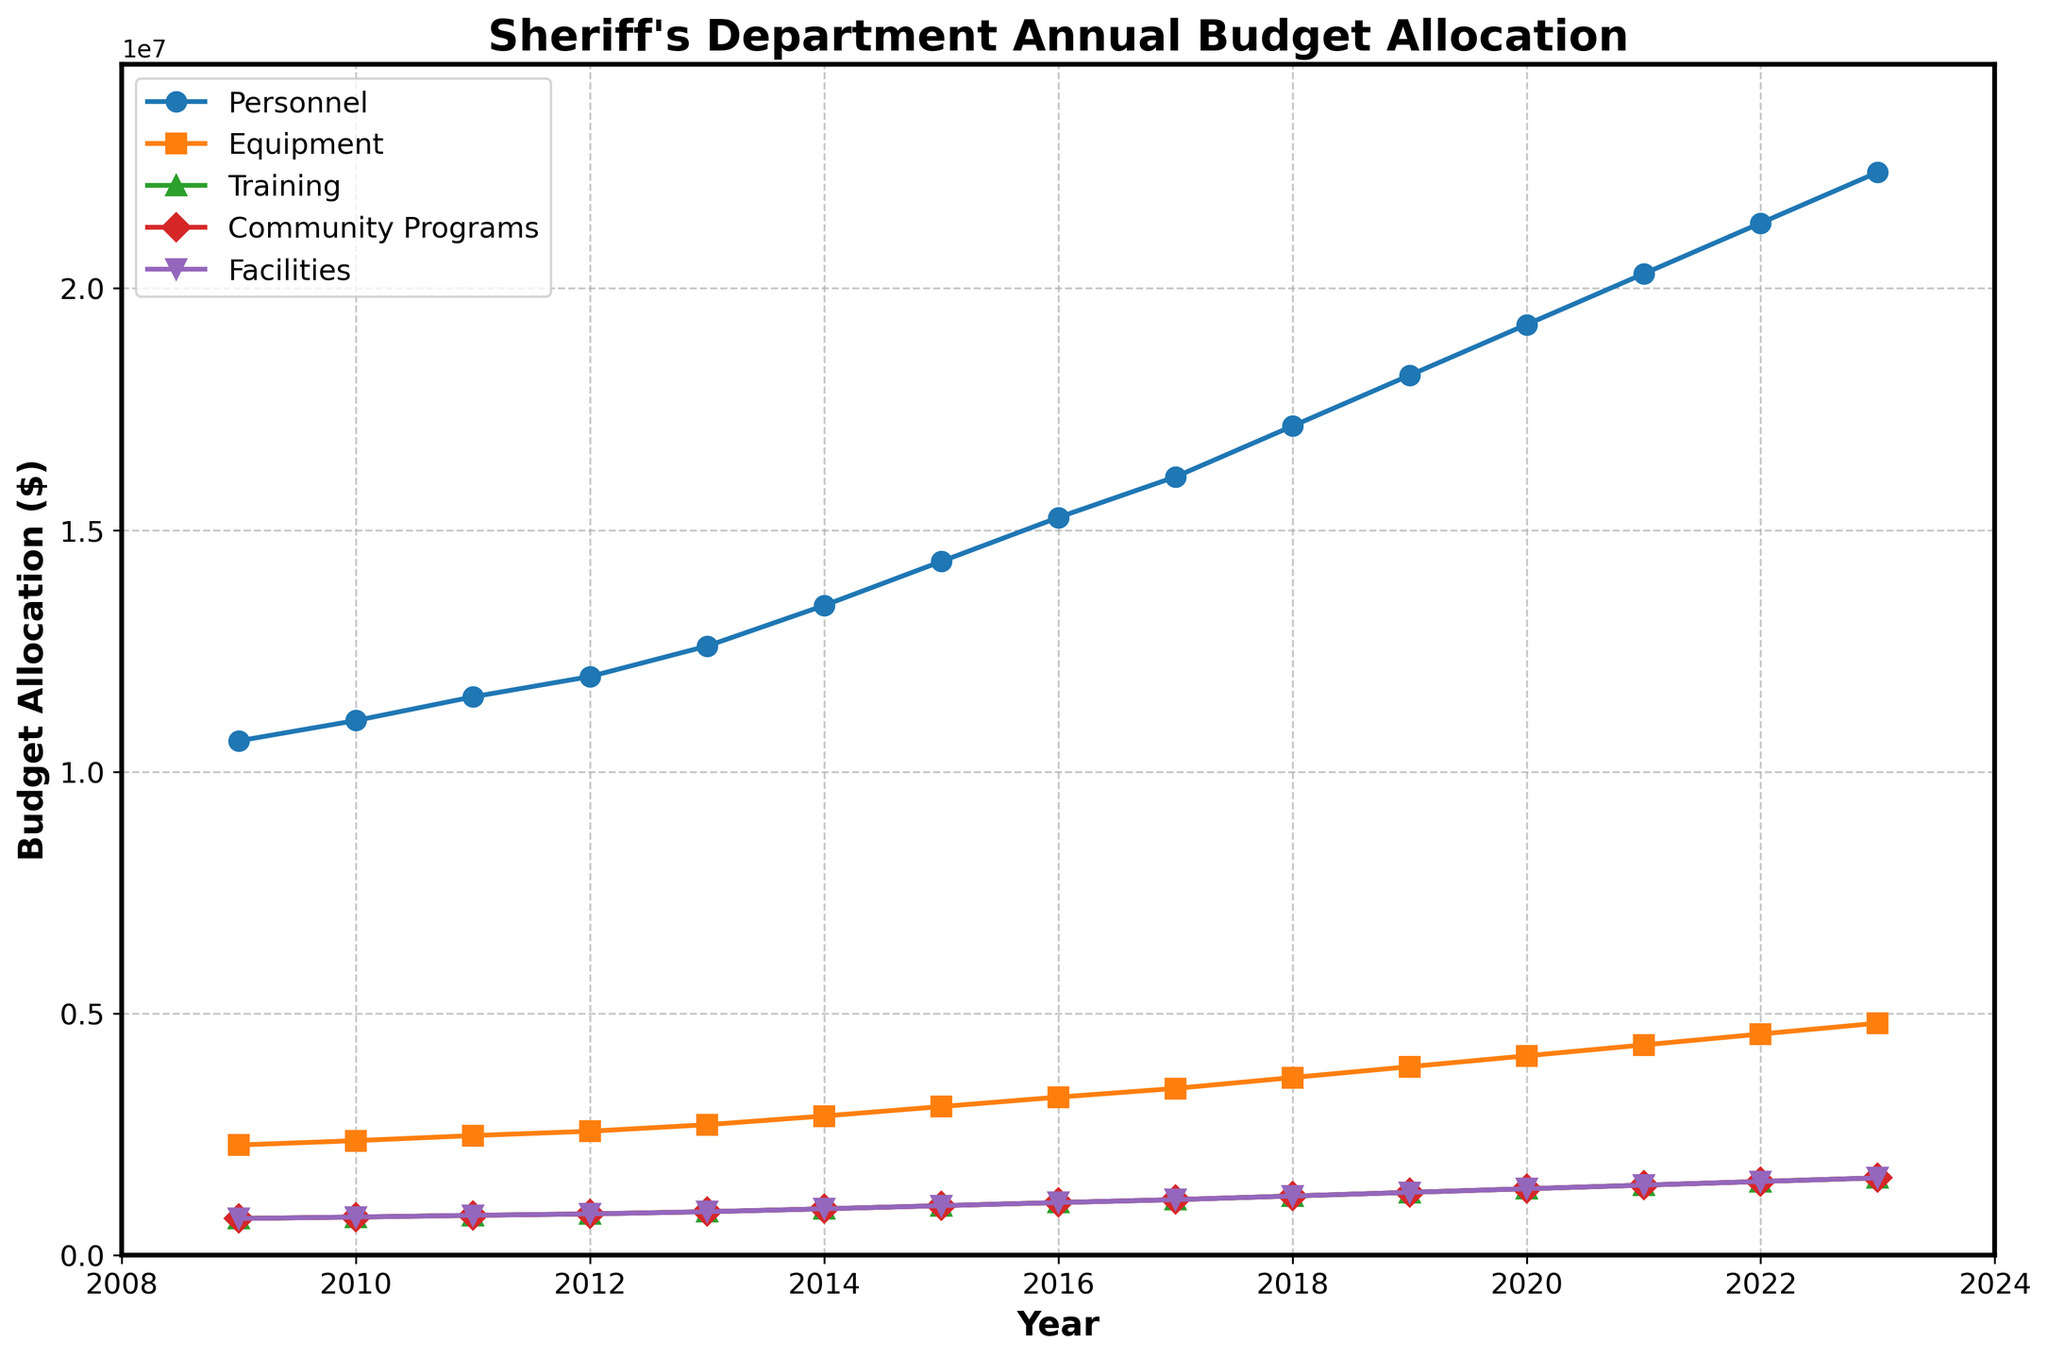What's the trend in the budget allocated for Personnel from 2009 to 2023? To identify the trend, observe the line representing Personnel. The line steadily increases from 2009 ($10.64M) to 2023 ($22.4M), indicating a positive trend.
Answer: Increasing Which expenditure category had the largest budget allocation in 2023? To find this, look at the values for 2023. Personnel has the highest allocation with $22.4 million.
Answer: Personnel How much did the total budget increase from 2010 to 2020? Subtract the total budget of 2010 ($15.8M) from the total budget of 2020 ($27.5M): $27.5M - $15.8M = $11.7M.
Answer: $11.7M Between which consecutive years was the greatest increase in the Equipment budget observed? To find this, calculate the year-to-year changes in the Equipment budget and identify the largest increase. The greatest increase occurred between 2022 ($4.575M) and 2023 ($4.8M), which is $0.225M.
Answer: 2022-2023 What is the average budget allocation for Training from 2011 to 2021? Sum the Training budgets from 2011 to 2021 and then divide by the number of years. The sum is $0.825M + $0.855M + ... + $1.45M = $11.30M. Dividing by 11 years gives $11.30M / 11 ≈ $1.027M.
Answer: $1.027M Which category consistently received the lowest budget allocation each year? By comparing the lines, Community Programs and Facilities have equal and lowest allocations each year.
Answer: Community Programs, Facilities By what percentage did the budget for Community Programs increase from 2015 to 2020? First, determine the increase: $1.375M - $1.025M = $0.35M. Then, the percentage increase is ($0.35M / $1.025M) * 100 ≈ 34.15%.
Answer: 34.15% In which year did the total budget first exceed $20 million? By inspecting the Total Budget line, the budget first exceeds $20M in 2015 ($20.5M).
Answer: 2015 What's the difference in the budget allocated to Facilities between 2009 and 2023? Subtract the 2009 Facilities budget ($0.76M) from the 2023 Facilities budget ($1.6M): $1.6M - $0.76M = $0.84M.
Answer: $0.84M 